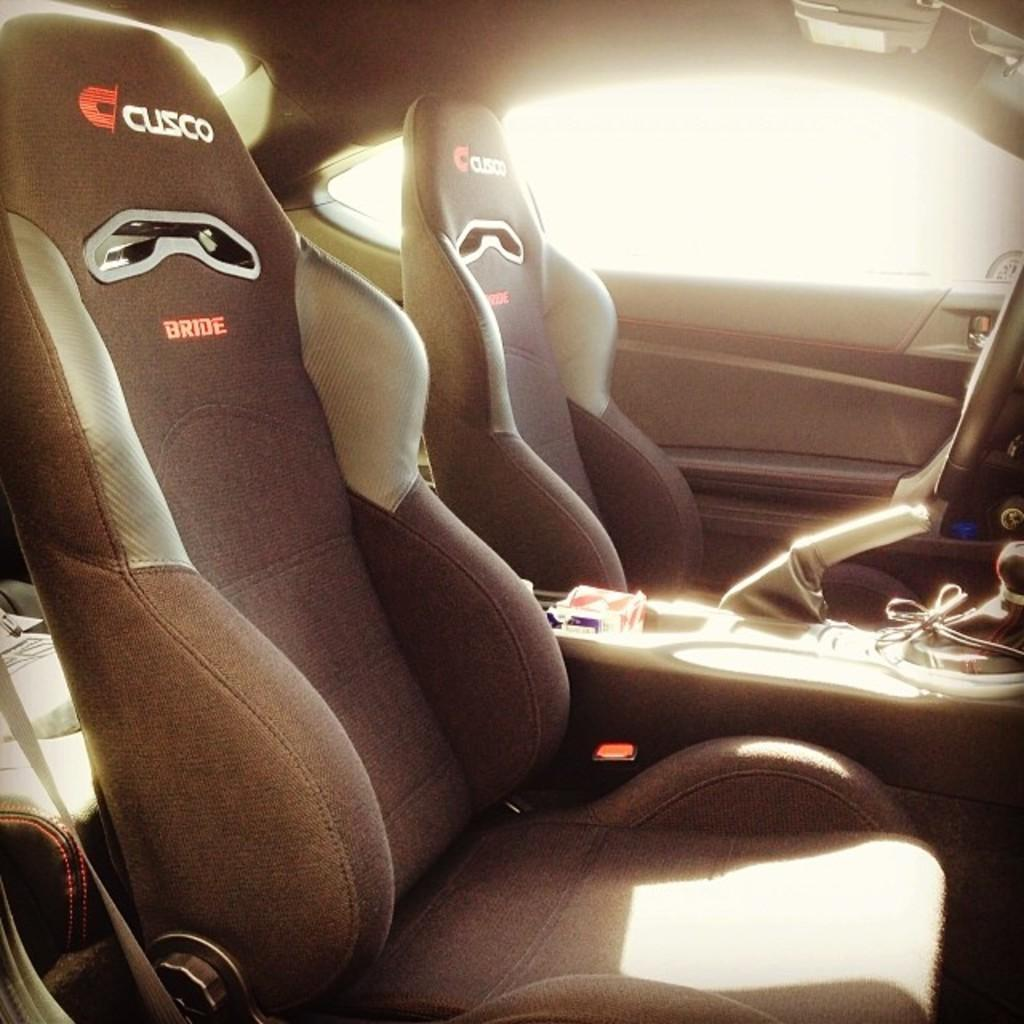What type of setting is depicted in the image? The image shows an inside view of a vehicle. How many seats are visible in the vehicle? There are two seats in the vehicle. What feature is present for controlling the vehicle's speed and direction? There is a gear rod in the vehicle for controlling the speed and direction. What allows passengers to see the outside environment while inside the vehicle? There is a window in the vehicle. What type of object is present for connecting or transmitting signals? There is a wire in the vehicle. What type of weather condition, such as sleet, can be seen coming down through the window in the image? There is no indication of any weather condition, such as sleet, coming down through the window in the image. Who is the representative of the vehicle manufacturer sitting in the vehicle in the image? There is no indication of any specific person or representative in the image. What type of plantation can be seen growing outside the window in the image? There is no plantation visible outside the window in the image. 